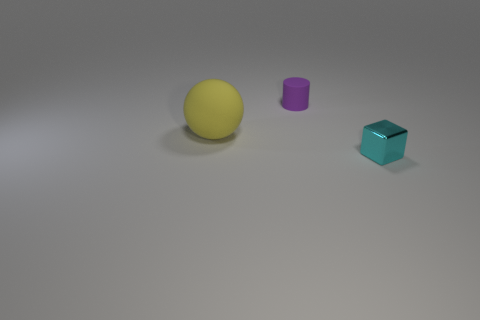Subtract 1 cubes. How many cubes are left? 0 Add 1 large gray rubber objects. How many objects exist? 4 Subtract all balls. How many objects are left? 2 Subtract 1 yellow spheres. How many objects are left? 2 Subtract all yellow cylinders. Subtract all green cubes. How many cylinders are left? 1 Subtract all big yellow spheres. Subtract all small cyan shiny things. How many objects are left? 1 Add 2 blocks. How many blocks are left? 3 Add 2 spheres. How many spheres exist? 3 